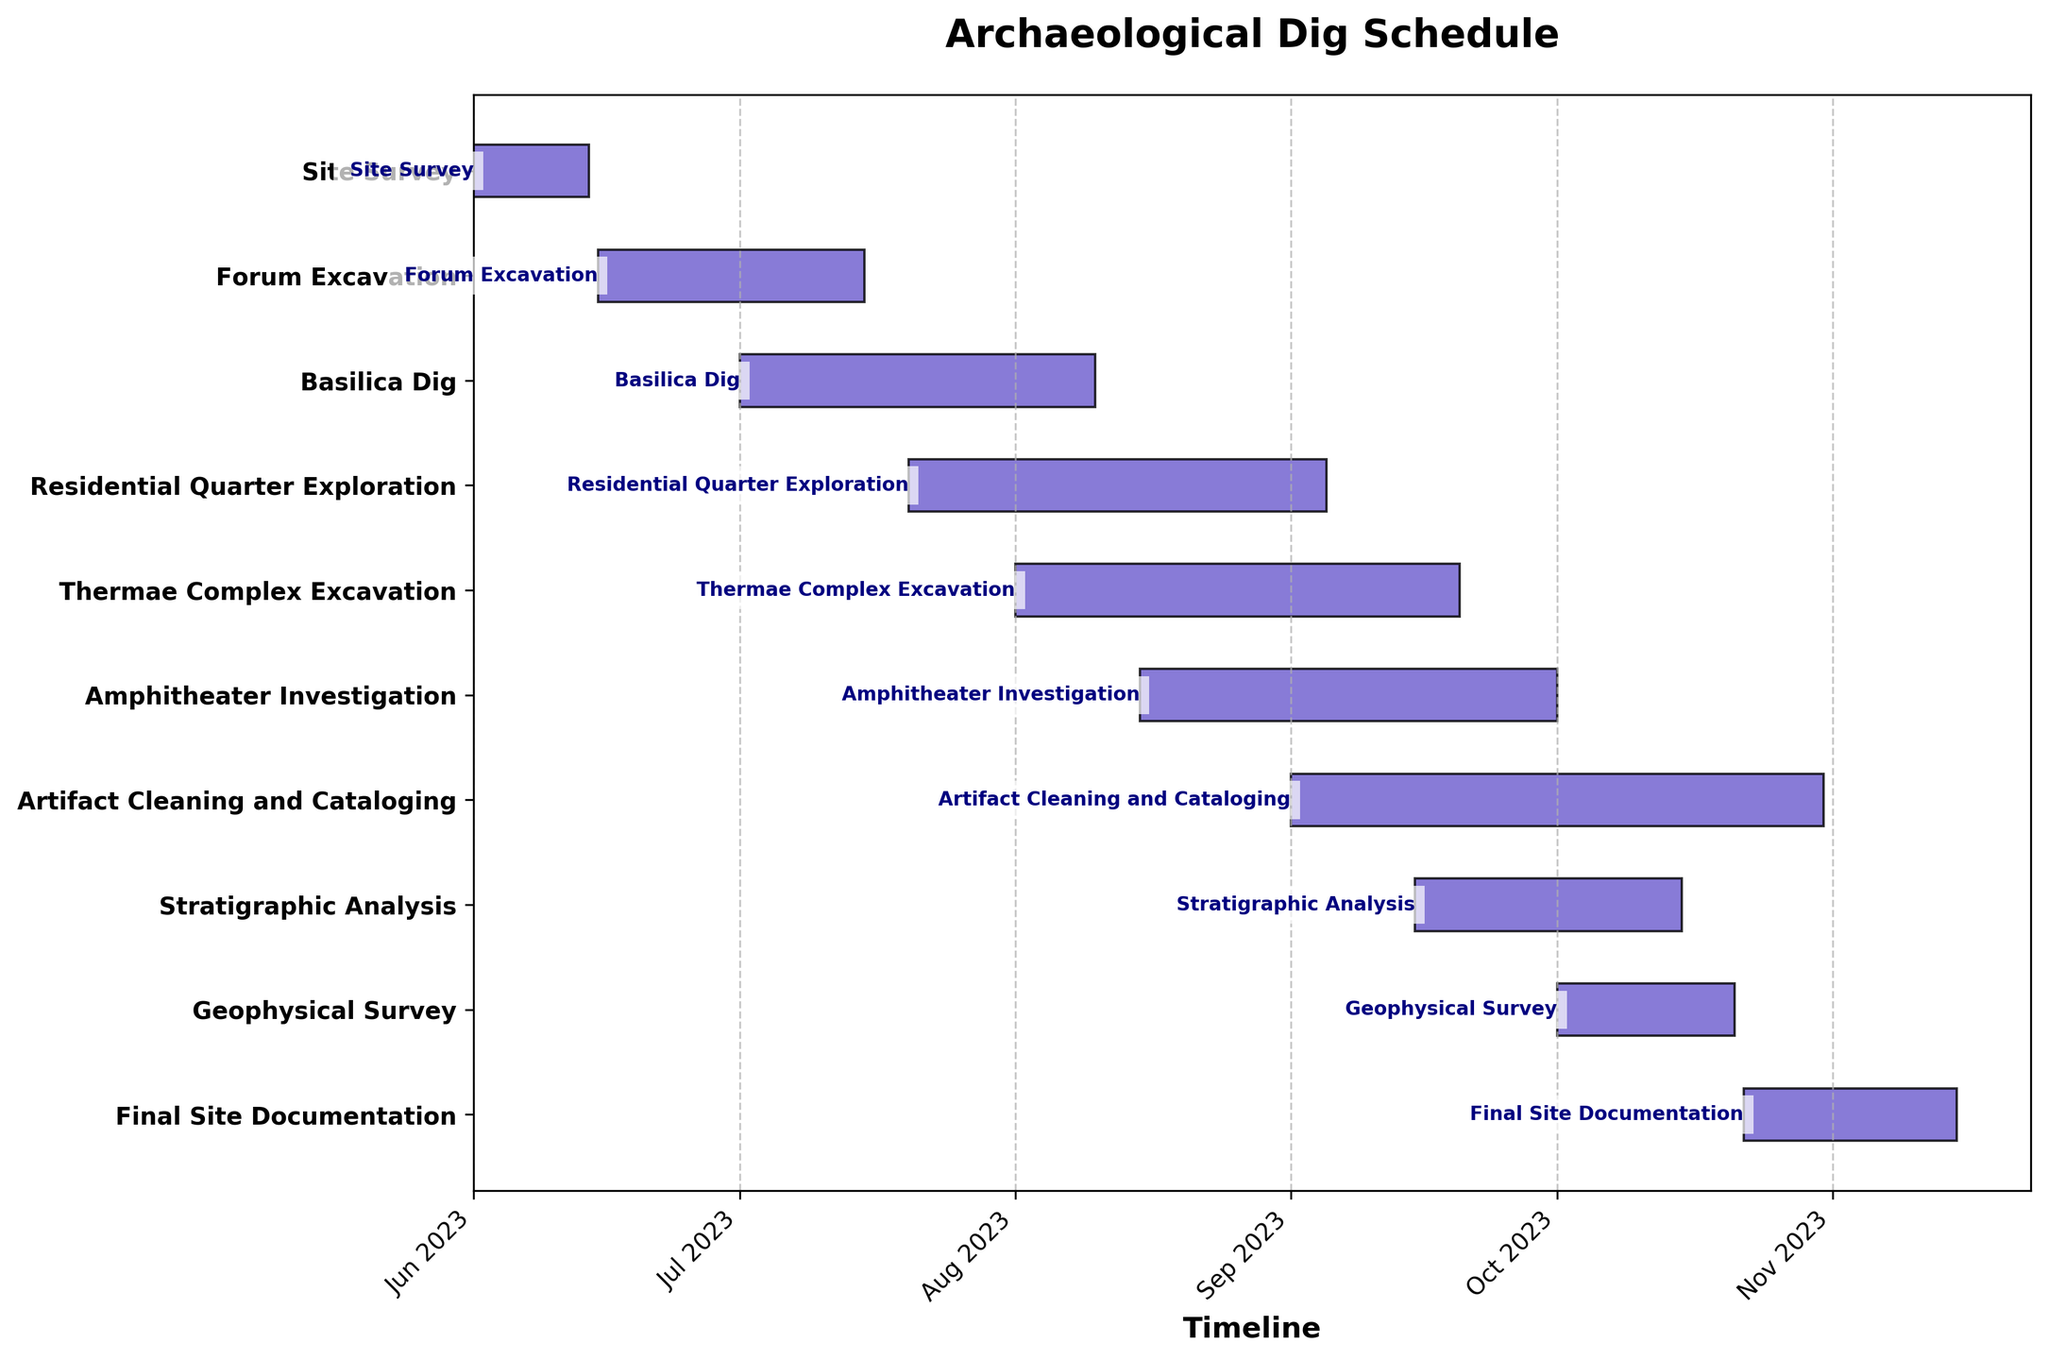What is the title of the Gantt chart? The title is often placed at the top of the chart and provides an overview of what the chart represents.
Answer: Archaeological Dig Schedule Which task starts first according to the Gantt chart? The tasks are listed in chronological order based on their start dates. The first task is the one with the earliest start date.
Answer: Site Survey How many days does the Geophysical Survey last? Calculate the duration by subtracting the start date from the end date (End Date - Start Date).
Answer: 20 days Which tasks overlap with the Basilica Dig? Identify the time span of the Basilica Dig and look for other tasks that share part of this time span. Tasks that share dates with the Basilica Dig are overlapping.
Answer: Residential Quarter Exploration, Thermae Complex Excavation, Amphitheater Investigation What is the total duration for the excavation of the Forum and Basilica combined? Sum the durations of the Forum Excavation and Basilica Dig.
Answer: 60 days (Forum: 30 days, Basilica: 40 days) Which task finishes last in the Gantt chart? The task with the latest end date will be the last completed.
Answer: Final Site Documentation How many tasks start in August? Count the tasks with a start date in the month of August.
Answer: 3 How long does the "Artifact Cleaning and Cataloging" task last, and when does it start? Read off the Gantt chart the start date of the task, and then calculate its duration by subtracting the start date from the end date.
Answer: 61 days, September 1 Which task has the shortest duration, and how long is it? Compare the durations of all tasks and identify the minimum.
Answer: Geophysical Survey, 20 days List the tasks that are carried out entirely in September. Look at the tasks' start and end dates and identify those that both start and end within September.
Answer: Residential Quarter Exploration, Thermae Complex Excavation, Artifact Cleaning and Cataloging 